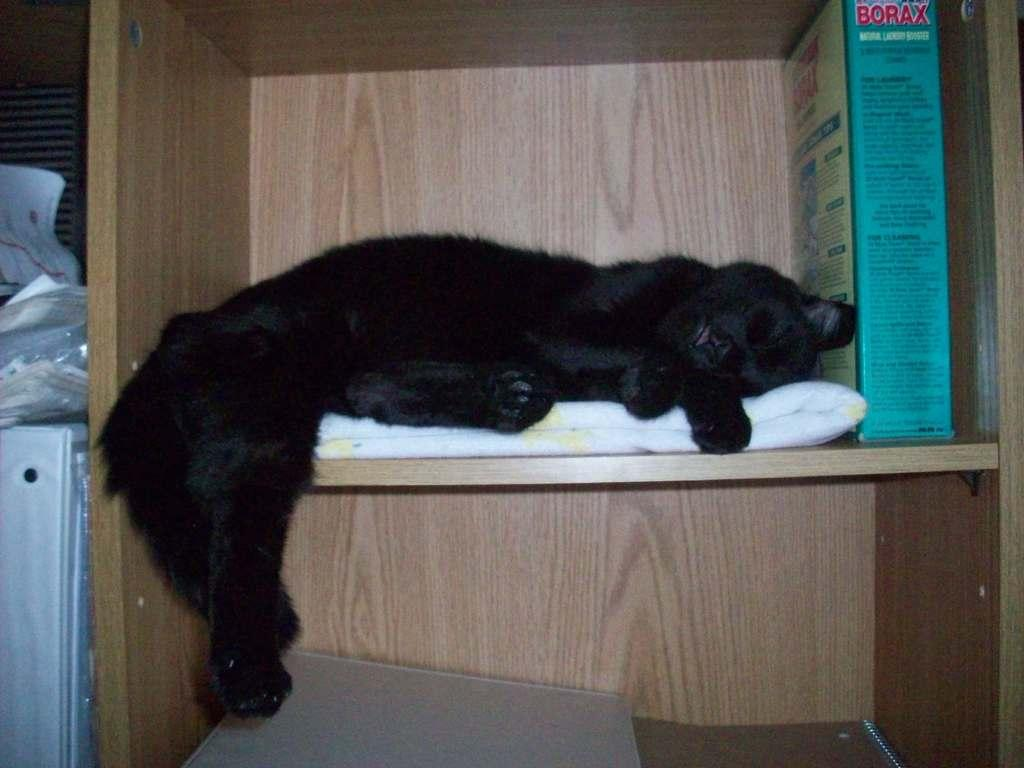What type of animal is in the image? The type of animal cannot be determined from the provided facts. What can be found inside the cupboard in the image? There are objects in a cupboard in the image, but their specific nature cannot be determined from the provided facts. What other objects are present in the image besides the animal and the objects in the cupboard? There are other objects present in the image, but their specific nature cannot be determined from the provided facts. What type of secretary is sitting next to the oatmeal in the image? There is no secretary or oatmeal present in the image. 